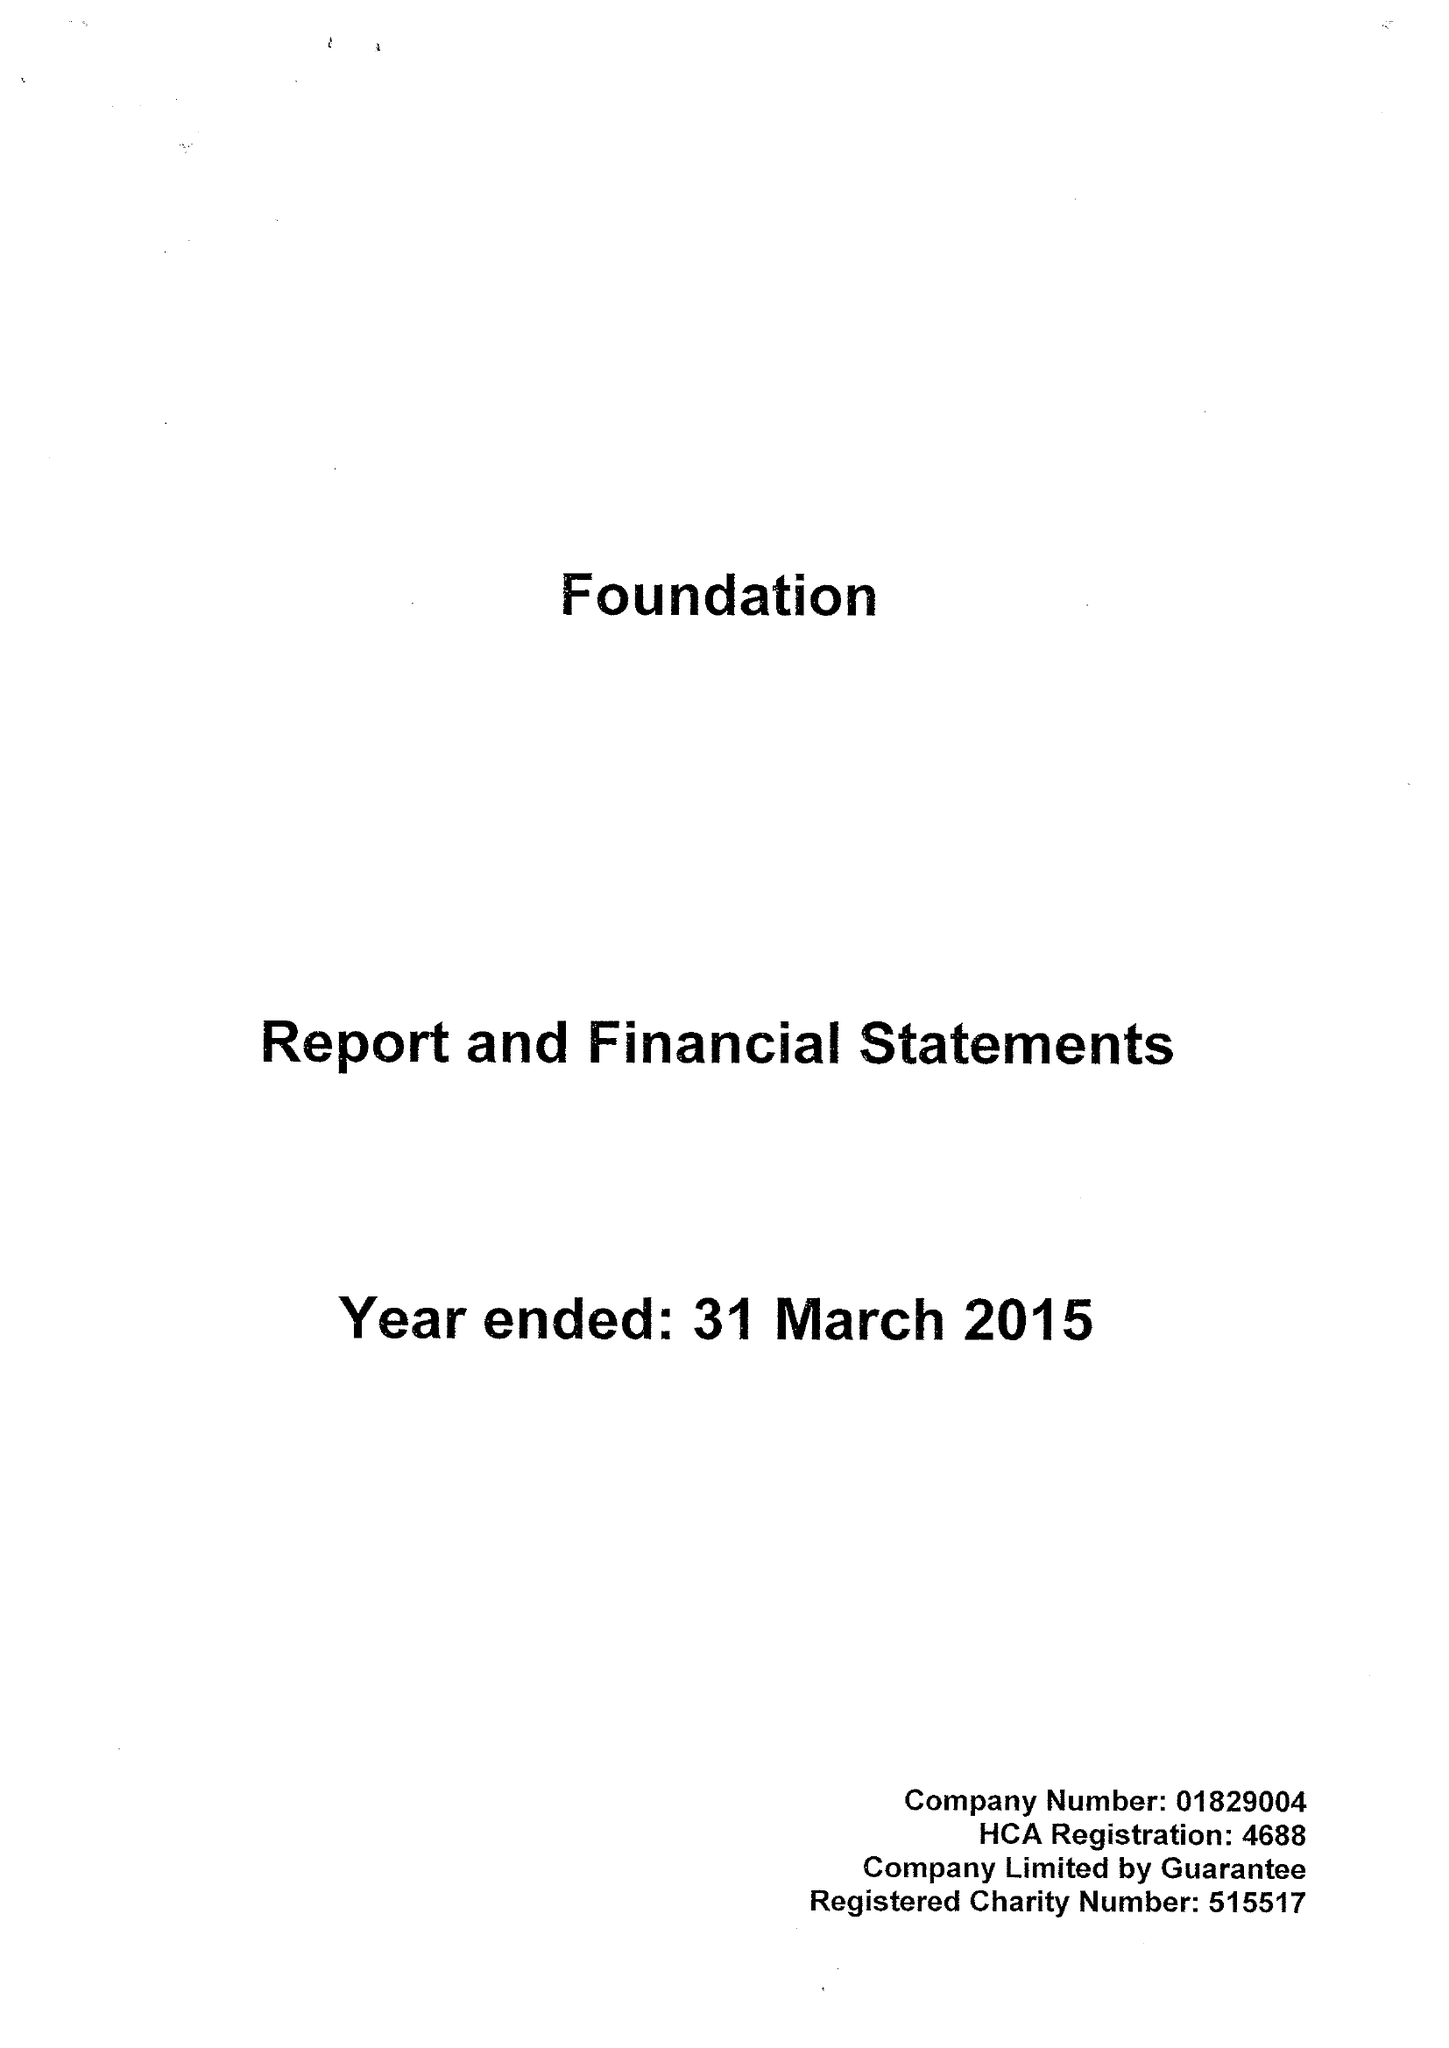What is the value for the income_annually_in_british_pounds?
Answer the question using a single word or phrase. 14331000.00 